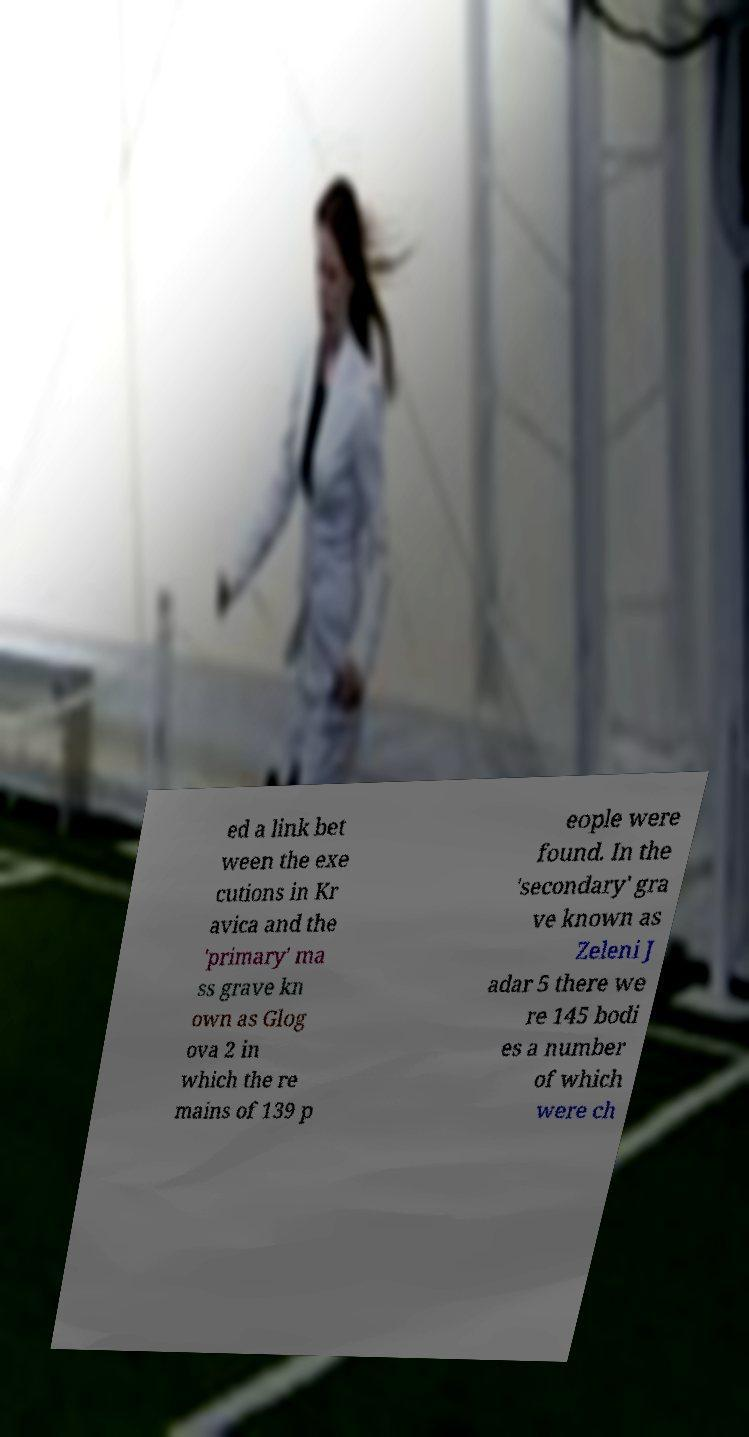For documentation purposes, I need the text within this image transcribed. Could you provide that? ed a link bet ween the exe cutions in Kr avica and the 'primary' ma ss grave kn own as Glog ova 2 in which the re mains of 139 p eople were found. In the 'secondary' gra ve known as Zeleni J adar 5 there we re 145 bodi es a number of which were ch 